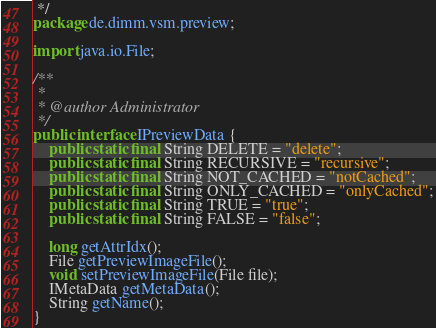Convert code to text. <code><loc_0><loc_0><loc_500><loc_500><_Java_> */
package de.dimm.vsm.preview;

import java.io.File;

/**
 *
 * @author Administrator
 */
public interface IPreviewData {   
    public static final String DELETE = "delete";
    public static final String RECURSIVE = "recursive";
    public static final String NOT_CACHED = "notCached";
    public static final String ONLY_CACHED = "onlyCached";
    public static final String TRUE = "true";
    public static final String FALSE = "false";
    
    long getAttrIdx();
    File getPreviewImageFile();
    void setPreviewImageFile(File file);
    IMetaData getMetaData();  
    String getName();
}
</code> 